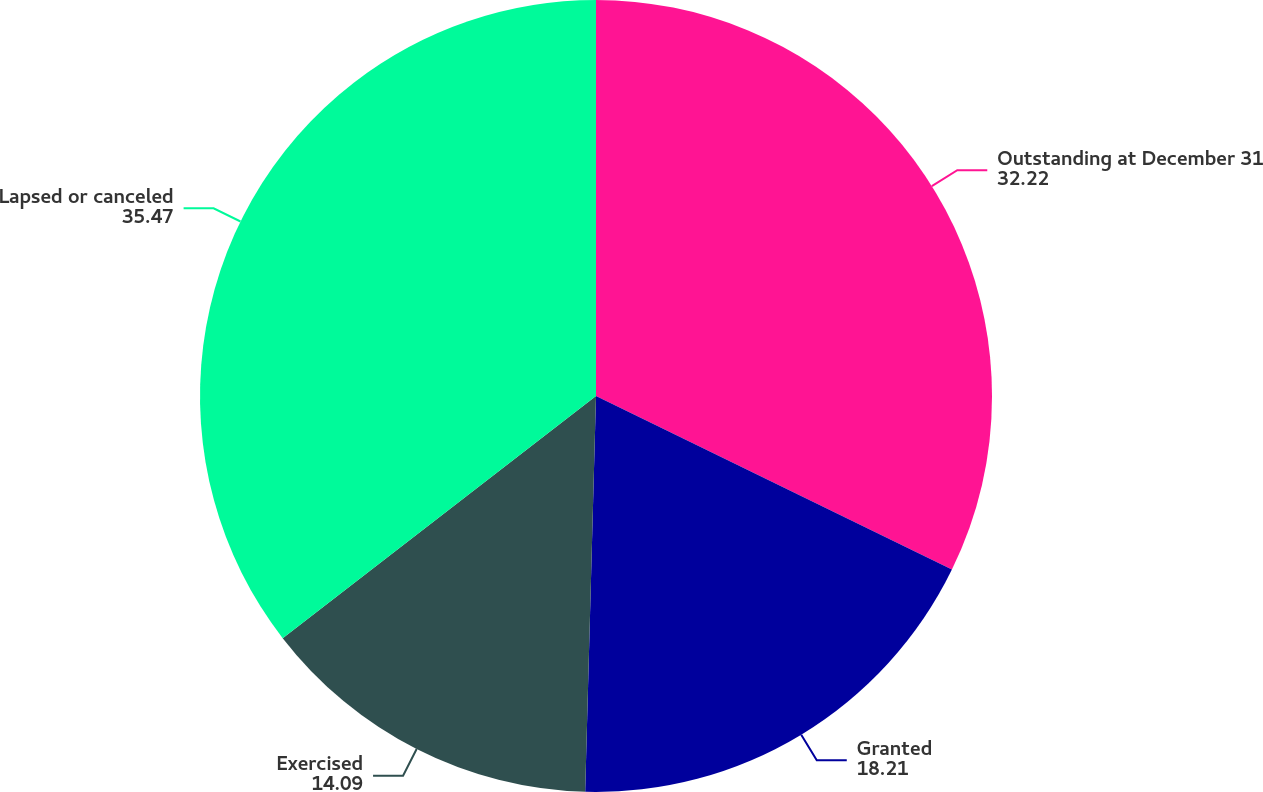Convert chart to OTSL. <chart><loc_0><loc_0><loc_500><loc_500><pie_chart><fcel>Outstanding at December 31<fcel>Granted<fcel>Exercised<fcel>Lapsed or canceled<nl><fcel>32.22%<fcel>18.21%<fcel>14.09%<fcel>35.47%<nl></chart> 